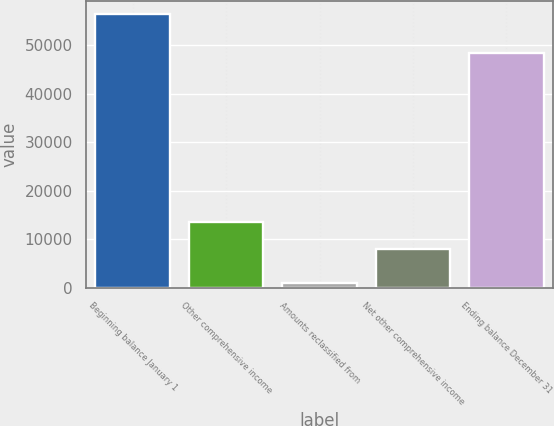<chart> <loc_0><loc_0><loc_500><loc_500><bar_chart><fcel>Beginning balance January 1<fcel>Other comprehensive income<fcel>Amounts reclassified from<fcel>Net other comprehensive income<fcel>Ending balance December 31<nl><fcel>56412<fcel>13515.6<fcel>956<fcel>7970<fcel>48442<nl></chart> 